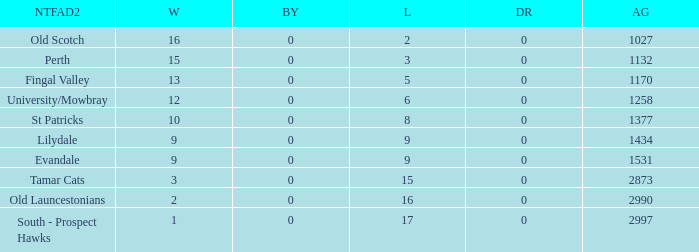What is the lowest number of draws of the NTFA Div 2 Lilydale? 0.0. 